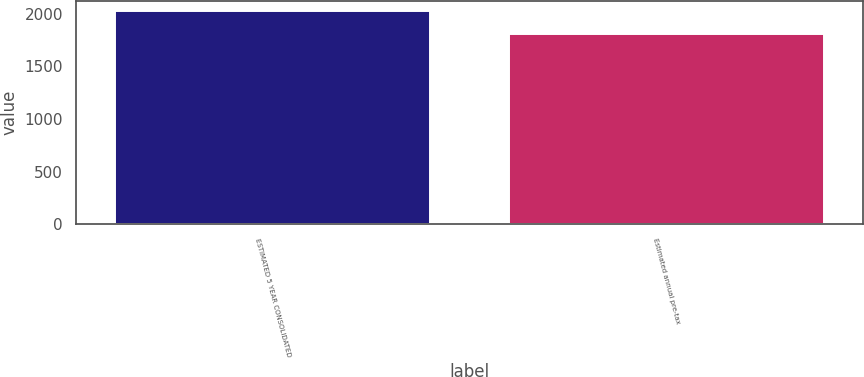Convert chart to OTSL. <chart><loc_0><loc_0><loc_500><loc_500><bar_chart><fcel>ESTIMATED 5 YEAR CONSOLIDATED<fcel>Estimated annual pre-tax<nl><fcel>2021<fcel>1810<nl></chart> 